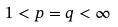<formula> <loc_0><loc_0><loc_500><loc_500>1 < p = q < \infty</formula> 